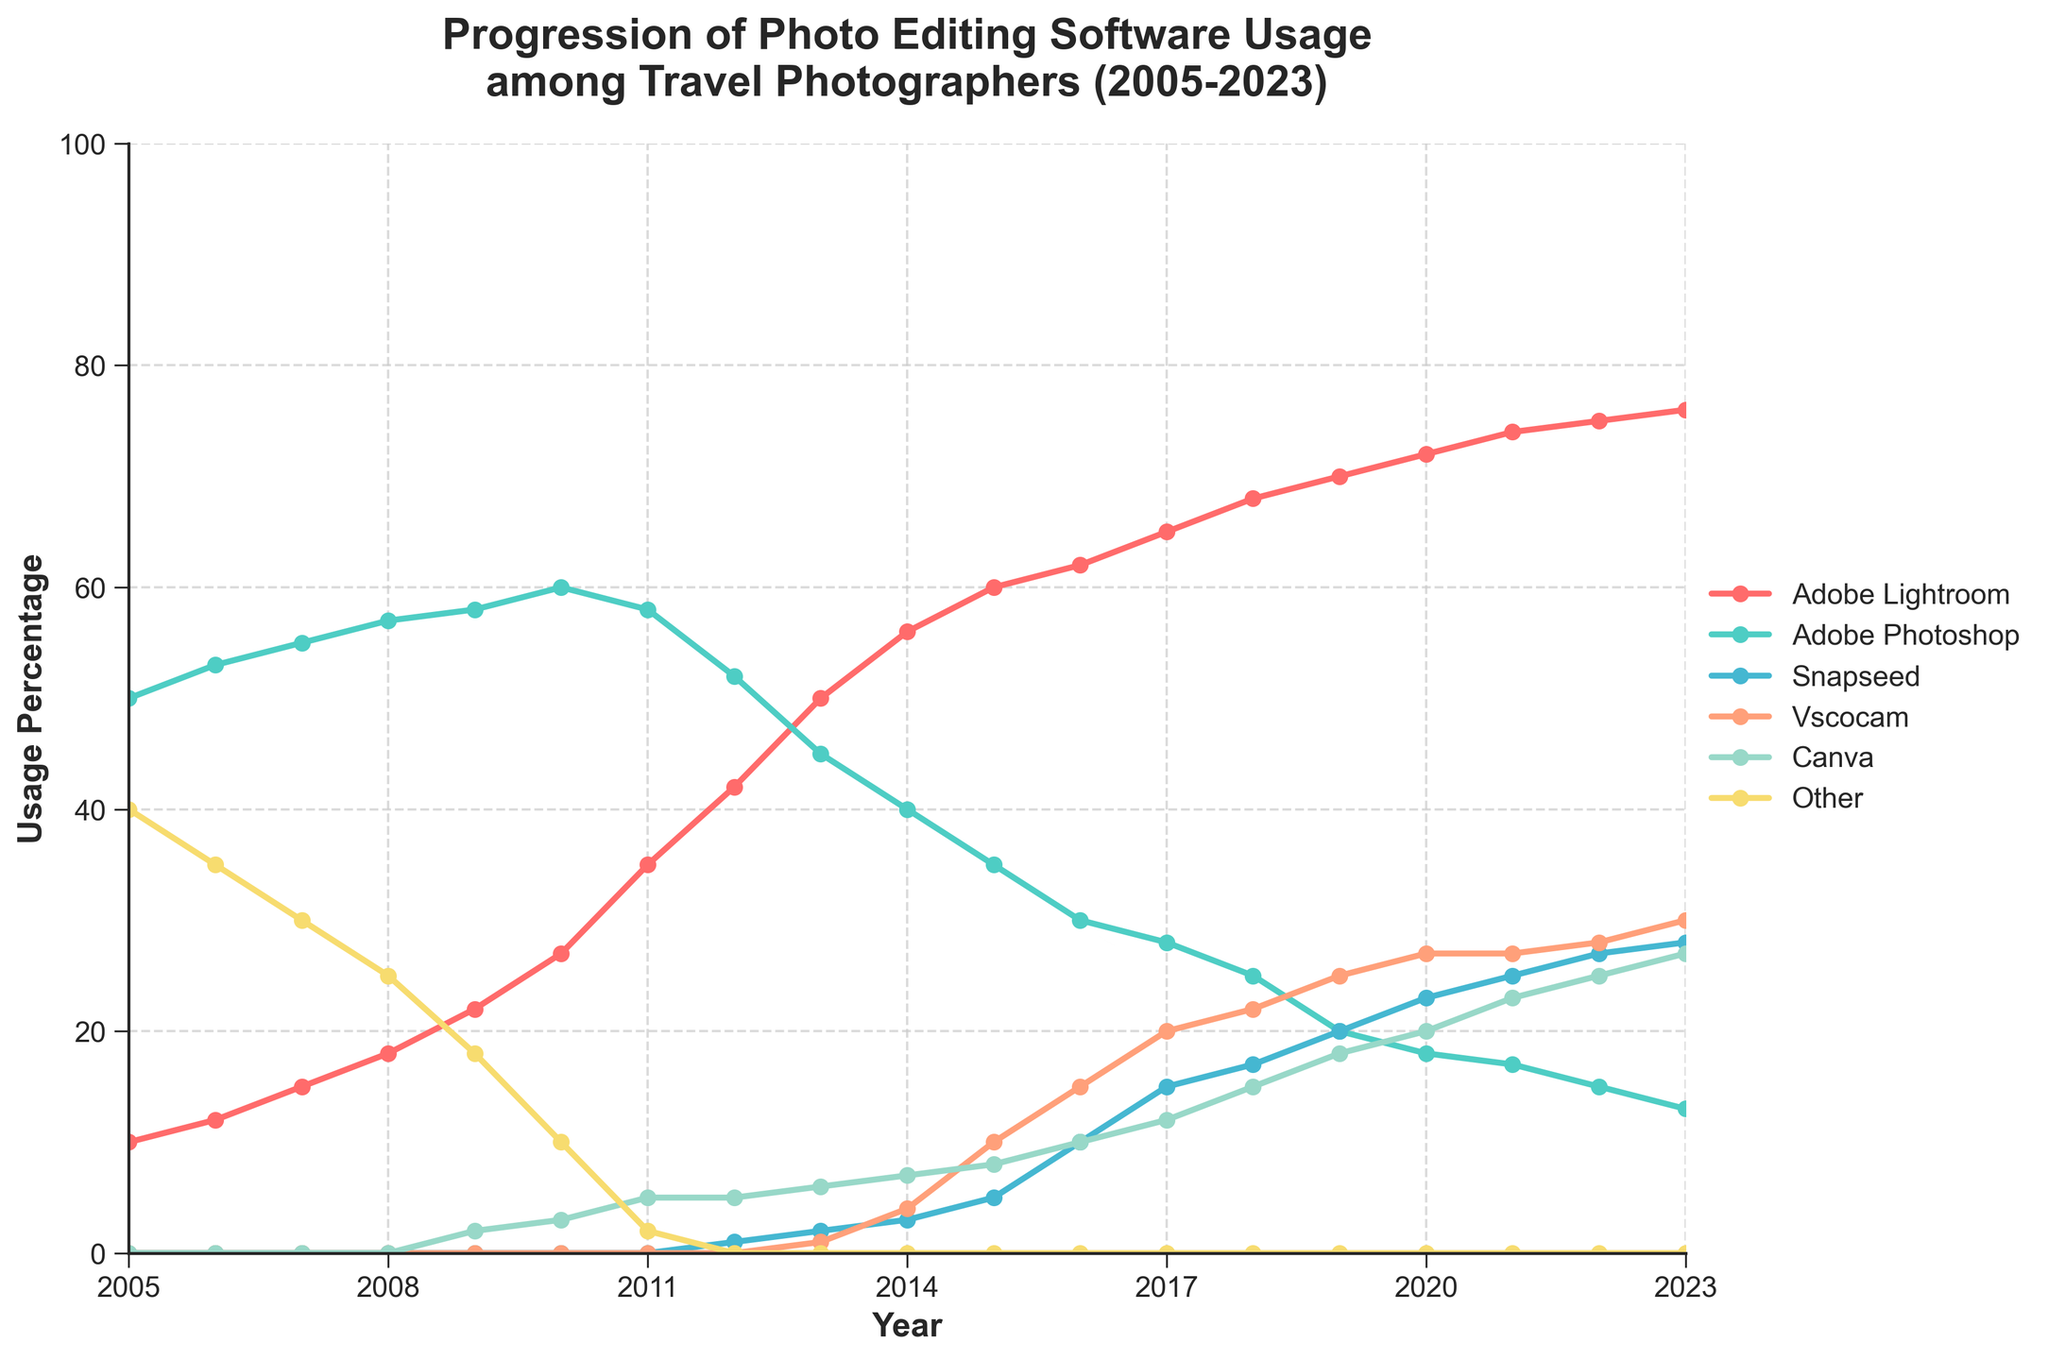What's the title of the figure? The title of the figure is usually found at the top and provides a summary of what the figure represents. Here, it is "Progression of Photo Editing Software Usage among Travel Photographers (2005-2023)".
Answer: Progression of Photo Editing Software Usage among Travel Photographers (2005-2023) What are the software types included in the figure? The different software types are typically listed in the legend of the plot, each associated with a line and color. In this figure, the software types are Adobe Lightroom, Adobe Photoshop, Snapseed, Vscocam, Canva, and Other.
Answer: Adobe Lightroom, Adobe Photoshop, Snapseed, Vscocam, Canva, Other Which software had the highest usage percentage in 2005? To find this, look at the data points for each software in the year 2005 and identify the one with the highest value. Adobe Photoshop had a usage of 50%, which is the highest for that year.
Answer: Adobe Photoshop In what year did Adobe Lightroom surpass Adobe Photoshop in usage percentage? To find this, look at the lines for both Adobe Lightroom and Adobe Photoshop, noting where the line for Lightroom goes above the line for Photoshop. This occurs between 2012 and 2013.
Answer: 2013 How did the usage percentage of Snapseed change from 2013 to 2018? To determine this, identify the 2013 and 2018 data points for Snapseed and calculate the change. In 2013, Snapseed had 2%, and in 2018 it had 17%, reflecting an increase of 15 percentage points.
Answer: Increased by 15 percentage points Which software showed a continuous increase in usage percentage from 2005 to 2023? By observing the trend lines, Adobe Lightroom shows a continuous increase in usage from 2005 to 2023 without any decline.
Answer: Adobe Lightroom Between Canva and Vscocam, which software had higher usage in 2023? Compare the 2023 data points for Canva and Vscocam. Canva has a usage of 27%, while Vscocam has 30%, making Vscocam higher.
Answer: Vscocam What is the total usage percentage of all listed software types in 2023? Sum the usage percentages of all the software types in 2023: Adobe Lightroom (76%), Adobe Photoshop (13%), Snapseed (28%), Vscocam (30%), Canva (27%), and Other (0%). The total is 76 + 13 + 28 + 30 + 27 + 0 = 174%.
Answer: 174% Which software had the biggest drop in usage percentage from its peak to 2023? Identify the peak and the 2023 value of each software, then calculate the drop. Adobe Photoshop peaked at 60% in 2010 and dropped to 13% in 2023, a decline of 47 percentage points, which is the largest drop.
Answer: Adobe Photoshop 